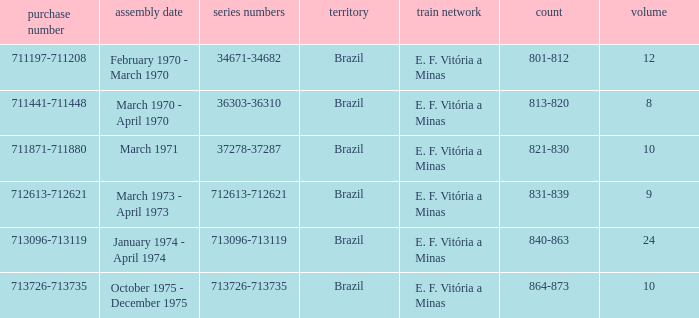What country has the order number 711871-711880? Brazil. 